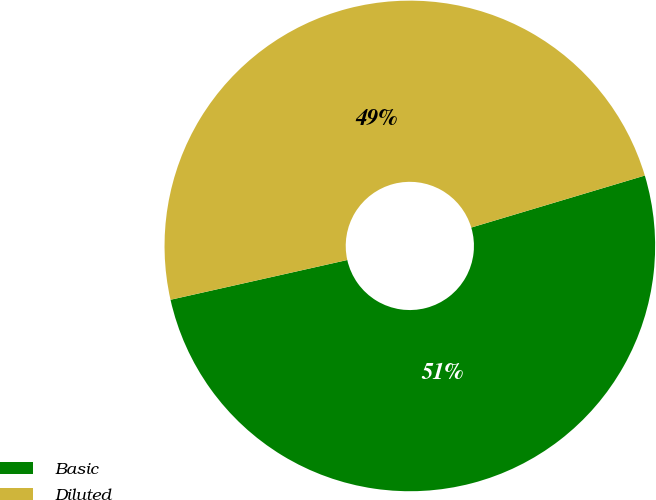Convert chart. <chart><loc_0><loc_0><loc_500><loc_500><pie_chart><fcel>Basic<fcel>Diluted<nl><fcel>51.11%<fcel>48.89%<nl></chart> 